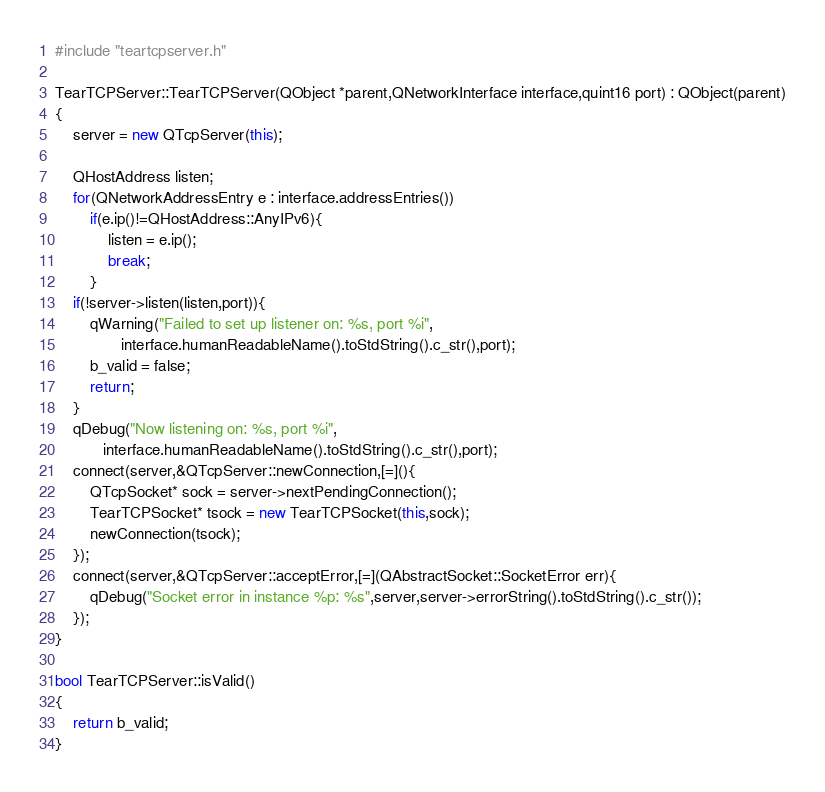Convert code to text. <code><loc_0><loc_0><loc_500><loc_500><_C++_>#include "teartcpserver.h"

TearTCPServer::TearTCPServer(QObject *parent,QNetworkInterface interface,quint16 port) : QObject(parent)
{
    server = new QTcpServer(this);

    QHostAddress listen;
    for(QNetworkAddressEntry e : interface.addressEntries())
        if(e.ip()!=QHostAddress::AnyIPv6){
            listen = e.ip();
            break;
        }
    if(!server->listen(listen,port)){
        qWarning("Failed to set up listener on: %s, port %i",
               interface.humanReadableName().toStdString().c_str(),port);
        b_valid = false;
        return;
    }
    qDebug("Now listening on: %s, port %i",
           interface.humanReadableName().toStdString().c_str(),port);
    connect(server,&QTcpServer::newConnection,[=](){
        QTcpSocket* sock = server->nextPendingConnection();
        TearTCPSocket* tsock = new TearTCPSocket(this,sock);
        newConnection(tsock);
    });
    connect(server,&QTcpServer::acceptError,[=](QAbstractSocket::SocketError err){
        qDebug("Socket error in instance %p: %s",server,server->errorString().toStdString().c_str());
    });
}

bool TearTCPServer::isValid()
{
    return b_valid;
}

</code> 